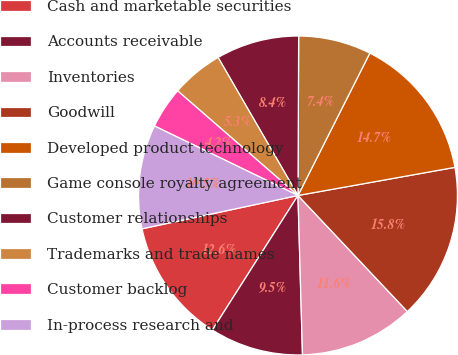Convert chart to OTSL. <chart><loc_0><loc_0><loc_500><loc_500><pie_chart><fcel>Cash and marketable securities<fcel>Accounts receivable<fcel>Inventories<fcel>Goodwill<fcel>Developed product technology<fcel>Game console royalty agreement<fcel>Customer relationships<fcel>Trademarks and trade names<fcel>Customer backlog<fcel>In-process research and<nl><fcel>12.63%<fcel>9.47%<fcel>11.58%<fcel>15.79%<fcel>14.74%<fcel>7.37%<fcel>8.42%<fcel>5.26%<fcel>4.21%<fcel>10.53%<nl></chart> 